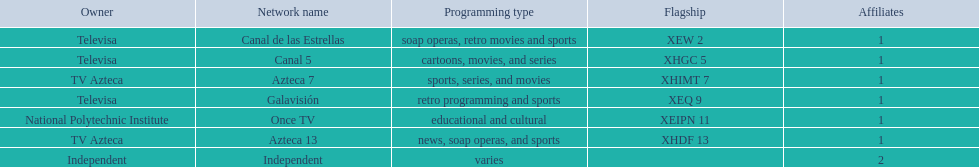What station shows cartoons? Canal 5. What station shows soap operas? Canal de las Estrellas. What station shows sports? Azteca 7. 